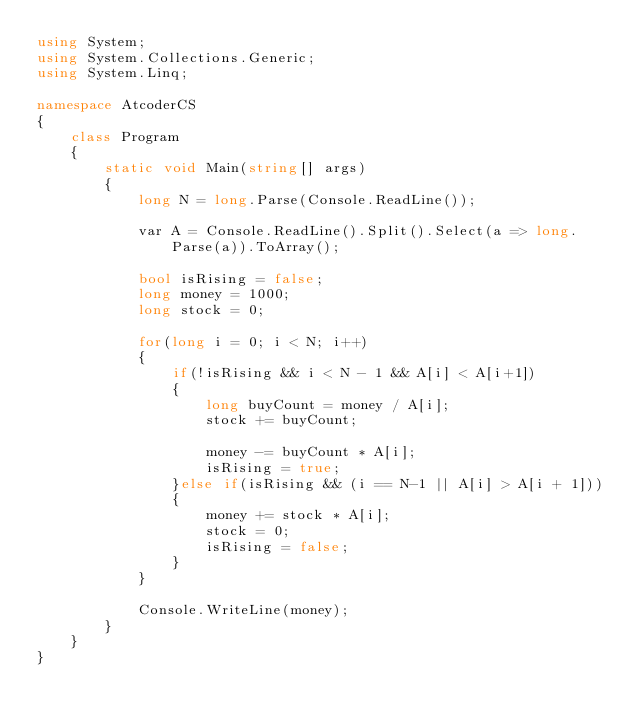<code> <loc_0><loc_0><loc_500><loc_500><_C#_>using System;
using System.Collections.Generic;
using System.Linq;

namespace AtcoderCS
{
    class Program
    {
        static void Main(string[] args)
        {
            long N = long.Parse(Console.ReadLine());

            var A = Console.ReadLine().Split().Select(a => long.Parse(a)).ToArray();

            bool isRising = false;
            long money = 1000;
            long stock = 0;

            for(long i = 0; i < N; i++)
            {
                if(!isRising && i < N - 1 && A[i] < A[i+1])
                {
                    long buyCount = money / A[i];
                    stock += buyCount;

                    money -= buyCount * A[i];
                    isRising = true;
                }else if(isRising && (i == N-1 || A[i] > A[i + 1]))
                {
                    money += stock * A[i];
                    stock = 0;
                    isRising = false;
                }
            }

            Console.WriteLine(money);
        }
    }
}
</code> 